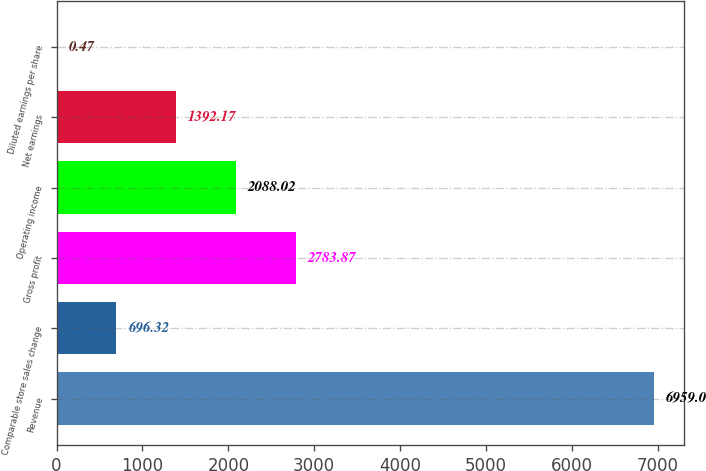Convert chart to OTSL. <chart><loc_0><loc_0><loc_500><loc_500><bar_chart><fcel>Revenue<fcel>Comparable store sales change<fcel>Gross profit<fcel>Operating income<fcel>Net earnings<fcel>Diluted earnings per share<nl><fcel>6959<fcel>696.32<fcel>2783.87<fcel>2088.02<fcel>1392.17<fcel>0.47<nl></chart> 